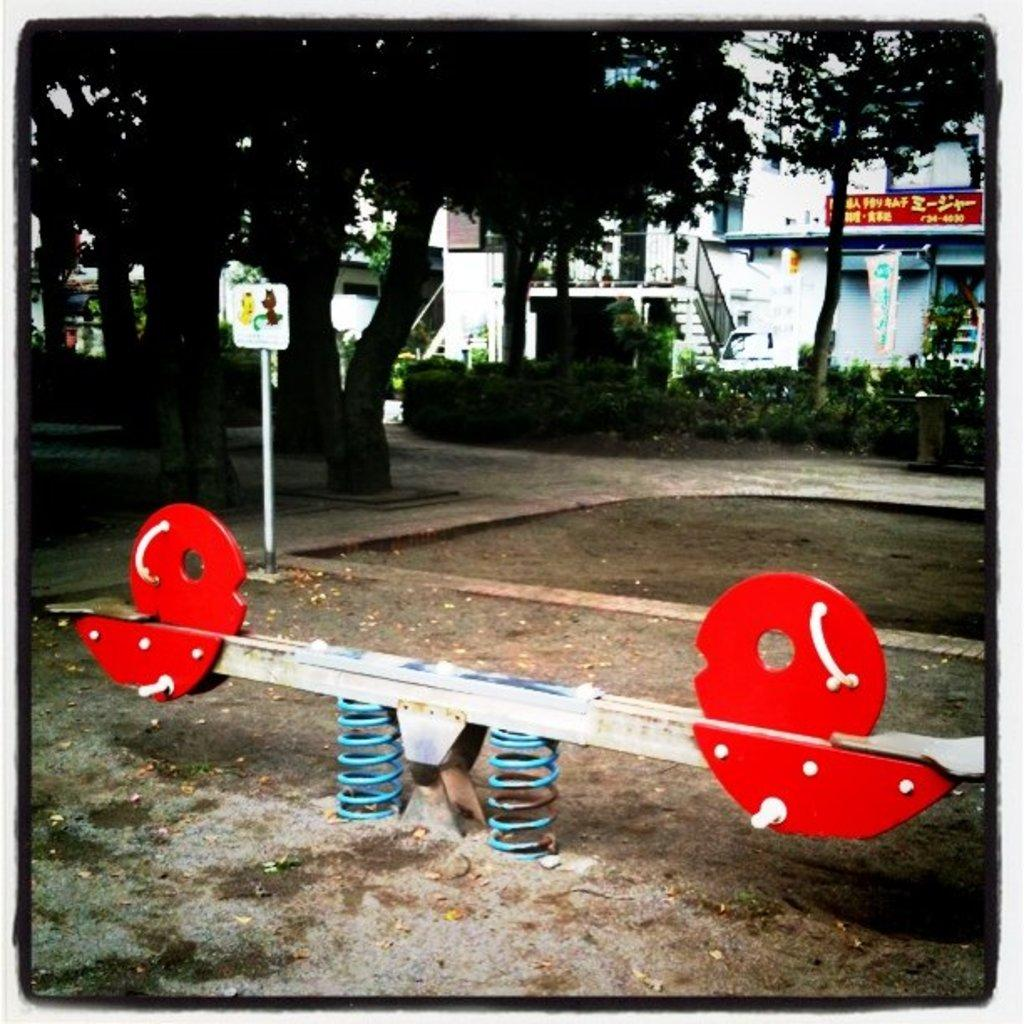What type of game is visible in the image? There is a see-saw game in the image. What type of surface is present in the image? There is sand in the image. What type of path is visible in the image? There is a road in the image. What type of natural elements are present in the image? There are trees and plants in the image. What type of man-made structures are present in the image? There are buildings in the image. What type of material is present in the image? There are boards in the image. How much money is being exchanged on the see-saw in the image? There is no money being exchanged in the image; it is a see-saw game. What type of button is present on the trees in the image? There are no buttons present on the trees in the image; there are only trees and plants. 